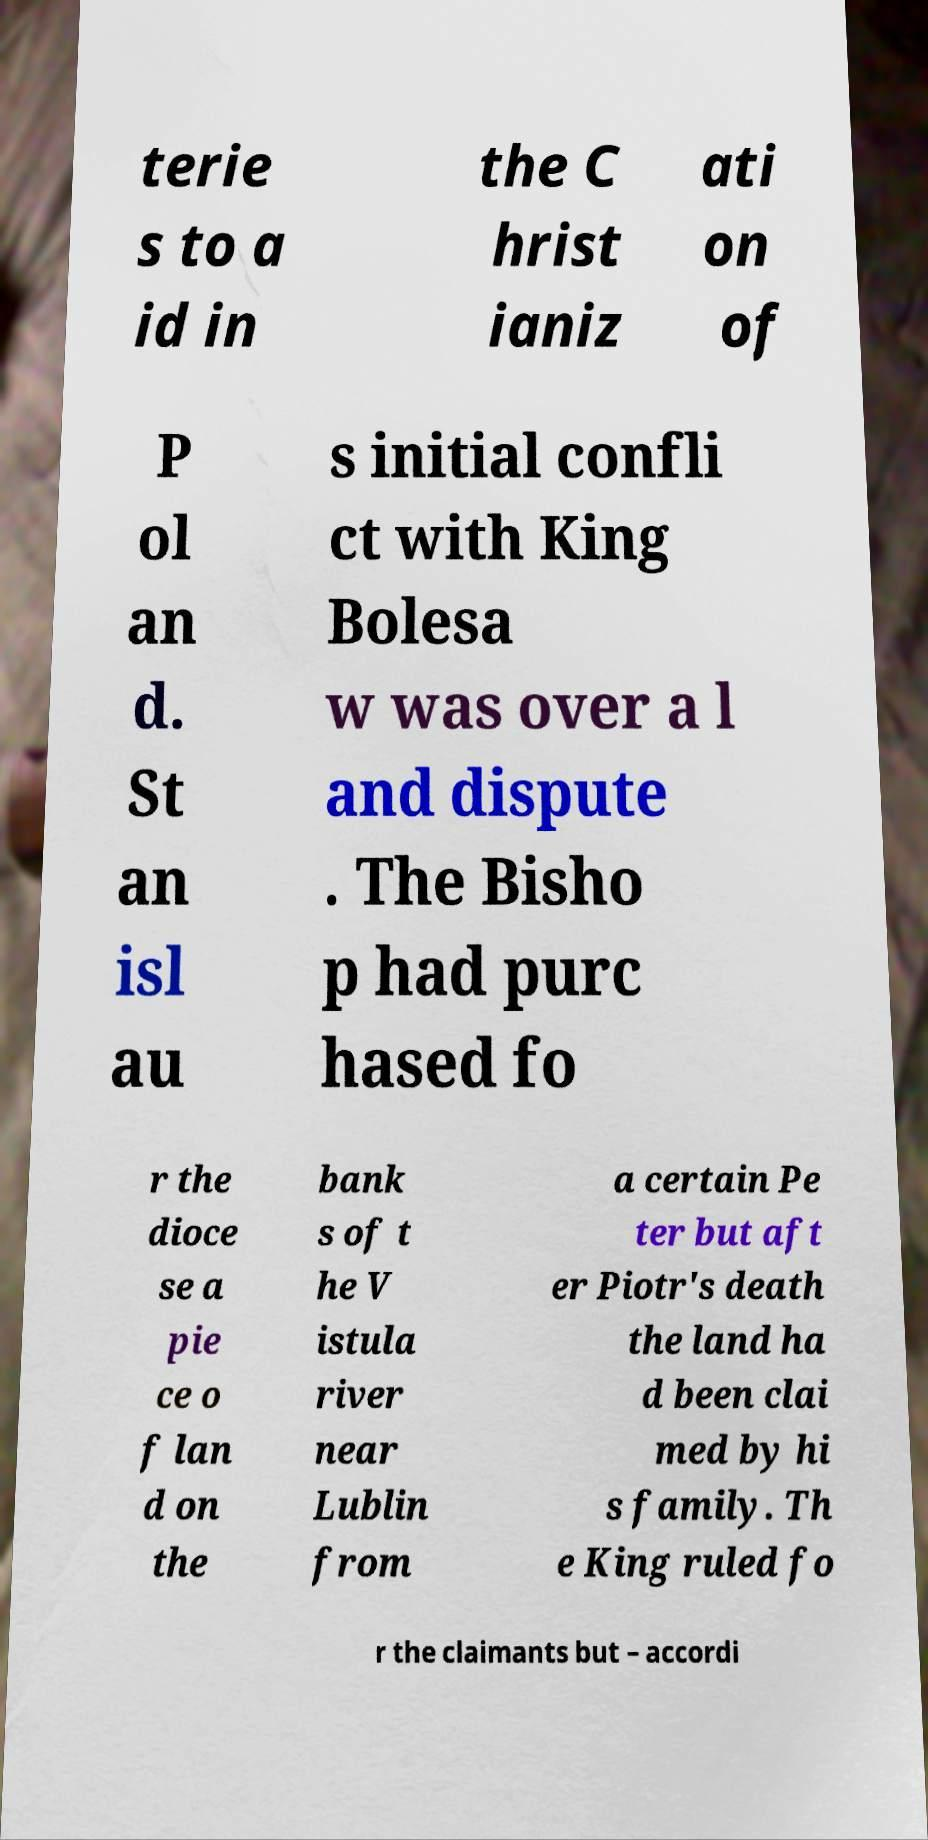Please identify and transcribe the text found in this image. terie s to a id in the C hrist ianiz ati on of P ol an d. St an isl au s initial confli ct with King Bolesa w was over a l and dispute . The Bisho p had purc hased fo r the dioce se a pie ce o f lan d on the bank s of t he V istula river near Lublin from a certain Pe ter but aft er Piotr's death the land ha d been clai med by hi s family. Th e King ruled fo r the claimants but – accordi 